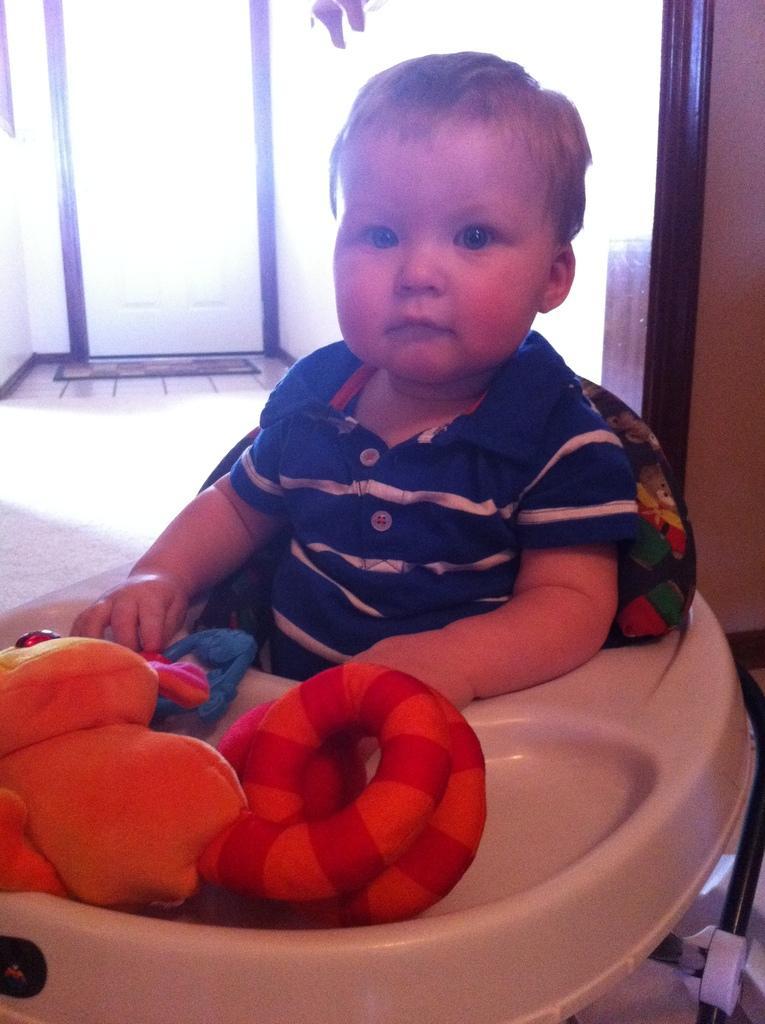How would you summarize this image in a sentence or two? In this image there is a kid sitting on a chair in front of him there are toys, in the background there is a wall for that wall there is a door. 